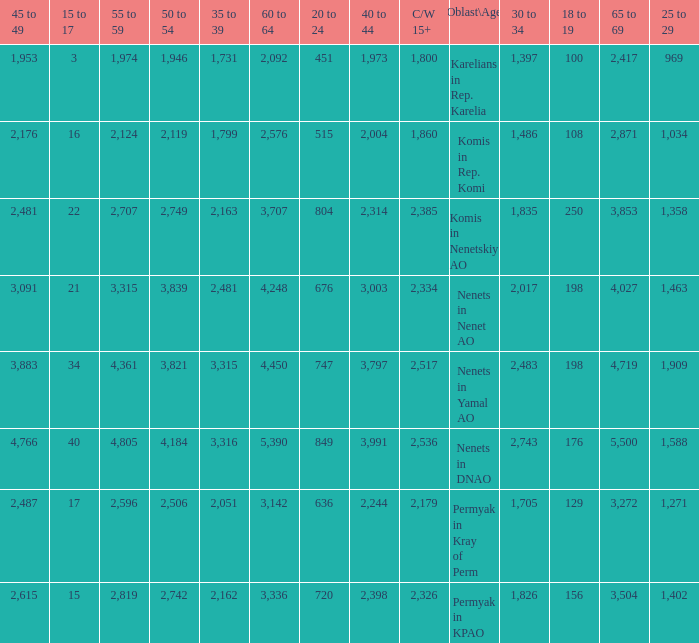Could you parse the entire table? {'header': ['45 to 49', '15 to 17', '55 to 59', '50 to 54', '35 to 39', '60 to 64', '20 to 24', '40 to 44', 'C/W 15+', 'Oblast\\Age', '30 to 34', '18 to 19', '65 to 69', '25 to 29'], 'rows': [['1,953', '3', '1,974', '1,946', '1,731', '2,092', '451', '1,973', '1,800', 'Karelians in Rep. Karelia', '1,397', '100', '2,417', '969'], ['2,176', '16', '2,124', '2,119', '1,799', '2,576', '515', '2,004', '1,860', 'Komis in Rep. Komi', '1,486', '108', '2,871', '1,034'], ['2,481', '22', '2,707', '2,749', '2,163', '3,707', '804', '2,314', '2,385', 'Komis in Nenetskiy AO', '1,835', '250', '3,853', '1,358'], ['3,091', '21', '3,315', '3,839', '2,481', '4,248', '676', '3,003', '2,334', 'Nenets in Nenet AO', '2,017', '198', '4,027', '1,463'], ['3,883', '34', '4,361', '3,821', '3,315', '4,450', '747', '3,797', '2,517', 'Nenets in Yamal AO', '2,483', '198', '4,719', '1,909'], ['4,766', '40', '4,805', '4,184', '3,316', '5,390', '849', '3,991', '2,536', 'Nenets in DNAO', '2,743', '176', '5,500', '1,588'], ['2,487', '17', '2,596', '2,506', '2,051', '3,142', '636', '2,244', '2,179', 'Permyak in Kray of Perm', '1,705', '129', '3,272', '1,271'], ['2,615', '15', '2,819', '2,742', '2,162', '3,336', '720', '2,398', '2,326', 'Permyak in KPAO', '1,826', '156', '3,504', '1,402']]} What is the mean 55 to 59 when the C/W 15+ is greater than 2,385, and the 30 to 34 is 2,483, and the 35 to 39 is greater than 3,315? None. 